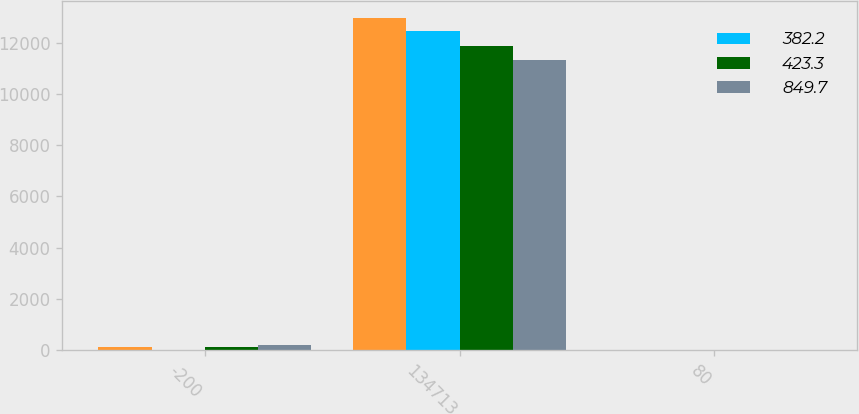Convert chart. <chart><loc_0><loc_0><loc_500><loc_500><stacked_bar_chart><ecel><fcel>-200<fcel>134713<fcel>80<nl><fcel>nan<fcel>100<fcel>12981.6<fcel>4.1<nl><fcel>382.2<fcel>0<fcel>12471.3<fcel>0<nl><fcel>423.3<fcel>100<fcel>11900.2<fcel>4.6<nl><fcel>849.7<fcel>200<fcel>11322.5<fcel>9.2<nl></chart> 